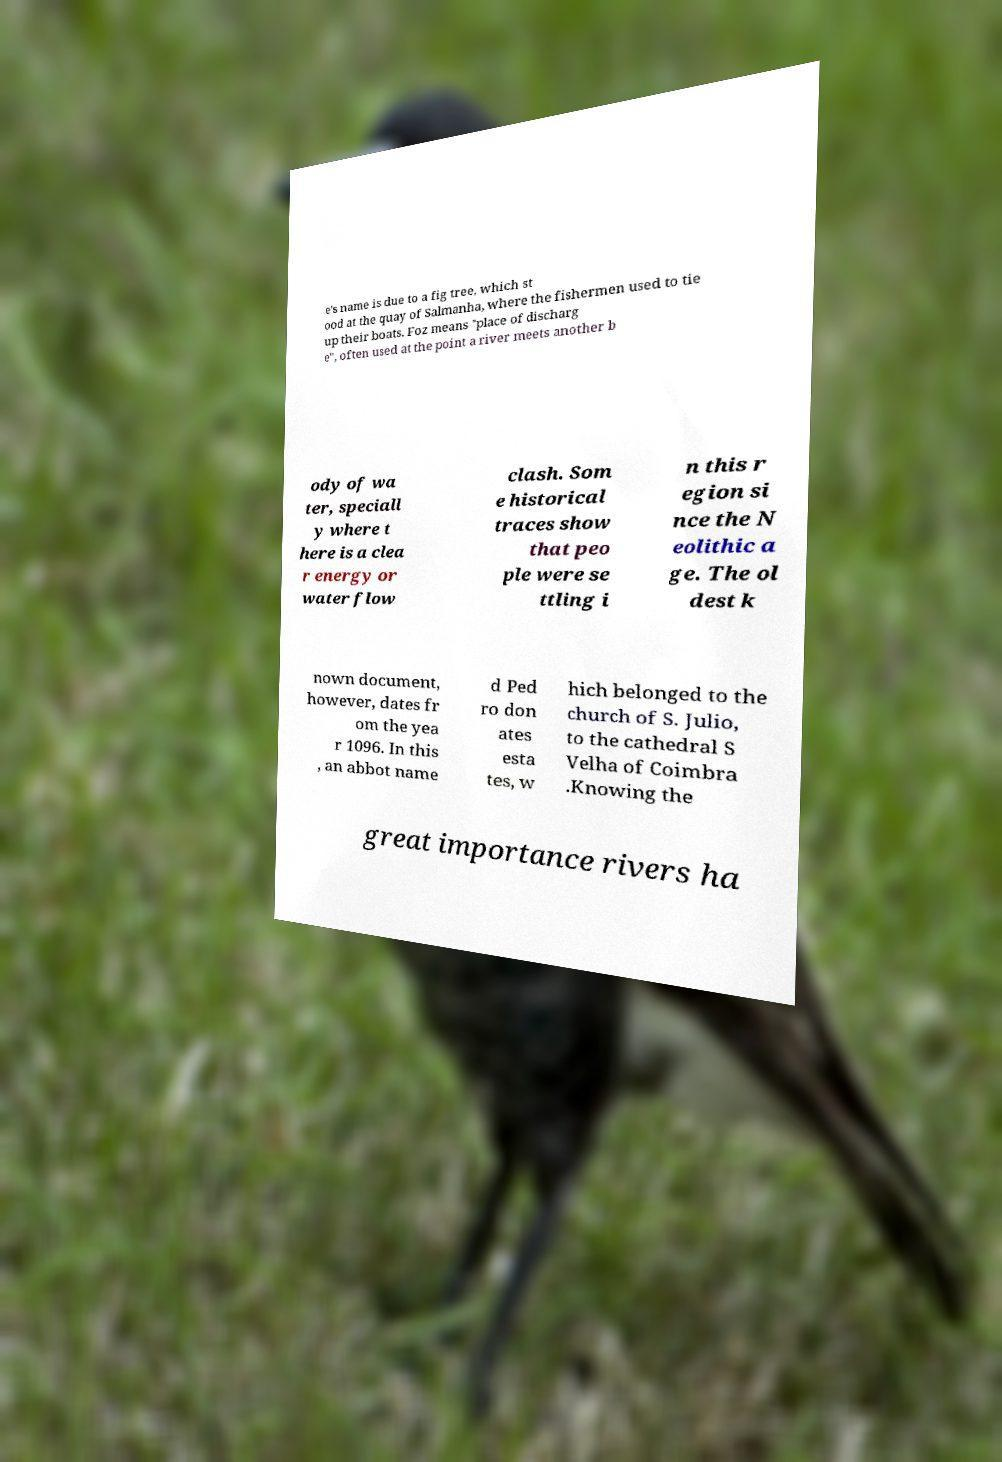Could you extract and type out the text from this image? e's name is due to a fig tree, which st ood at the quay of Salmanha, where the fishermen used to tie up their boats. Foz means "place of discharg e", often used at the point a river meets another b ody of wa ter, speciall y where t here is a clea r energy or water flow clash. Som e historical traces show that peo ple were se ttling i n this r egion si nce the N eolithic a ge. The ol dest k nown document, however, dates fr om the yea r 1096. In this , an abbot name d Ped ro don ates esta tes, w hich belonged to the church of S. Julio, to the cathedral S Velha of Coimbra .Knowing the great importance rivers ha 